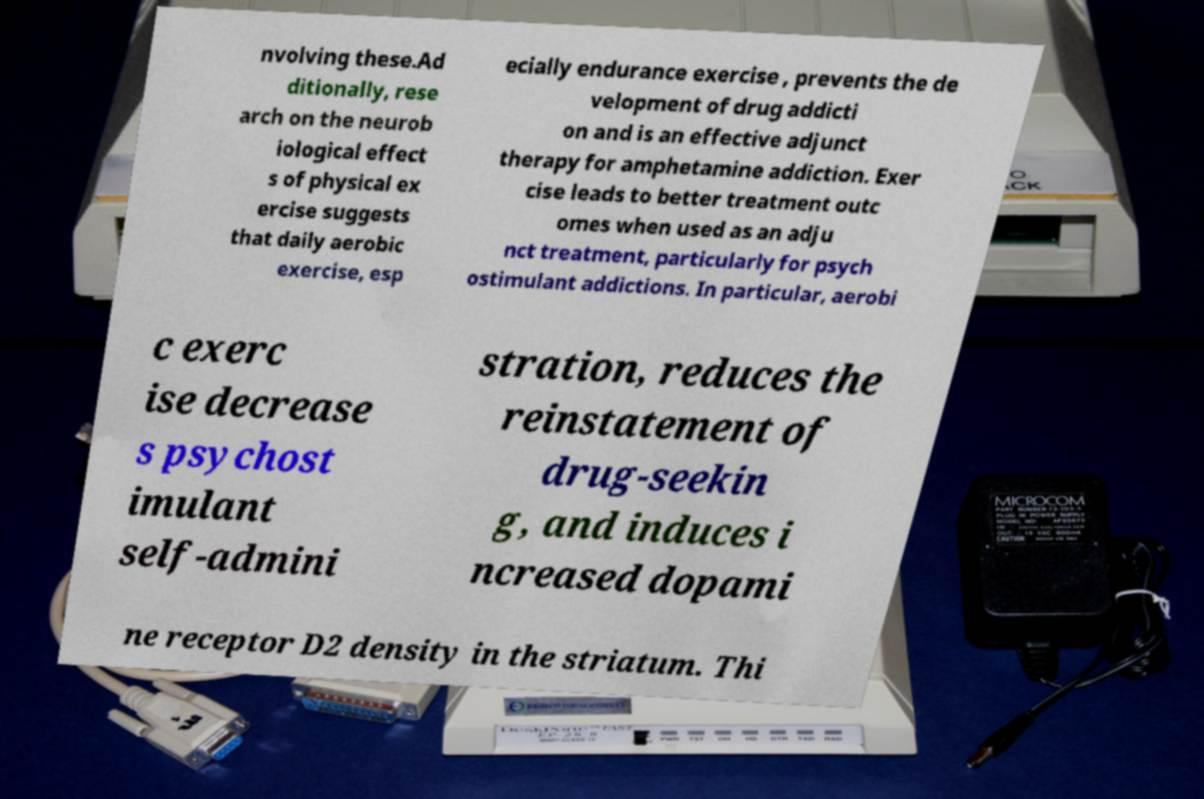What messages or text are displayed in this image? I need them in a readable, typed format. nvolving these.Ad ditionally, rese arch on the neurob iological effect s of physical ex ercise suggests that daily aerobic exercise, esp ecially endurance exercise , prevents the de velopment of drug addicti on and is an effective adjunct therapy for amphetamine addiction. Exer cise leads to better treatment outc omes when used as an adju nct treatment, particularly for psych ostimulant addictions. In particular, aerobi c exerc ise decrease s psychost imulant self-admini stration, reduces the reinstatement of drug-seekin g, and induces i ncreased dopami ne receptor D2 density in the striatum. Thi 